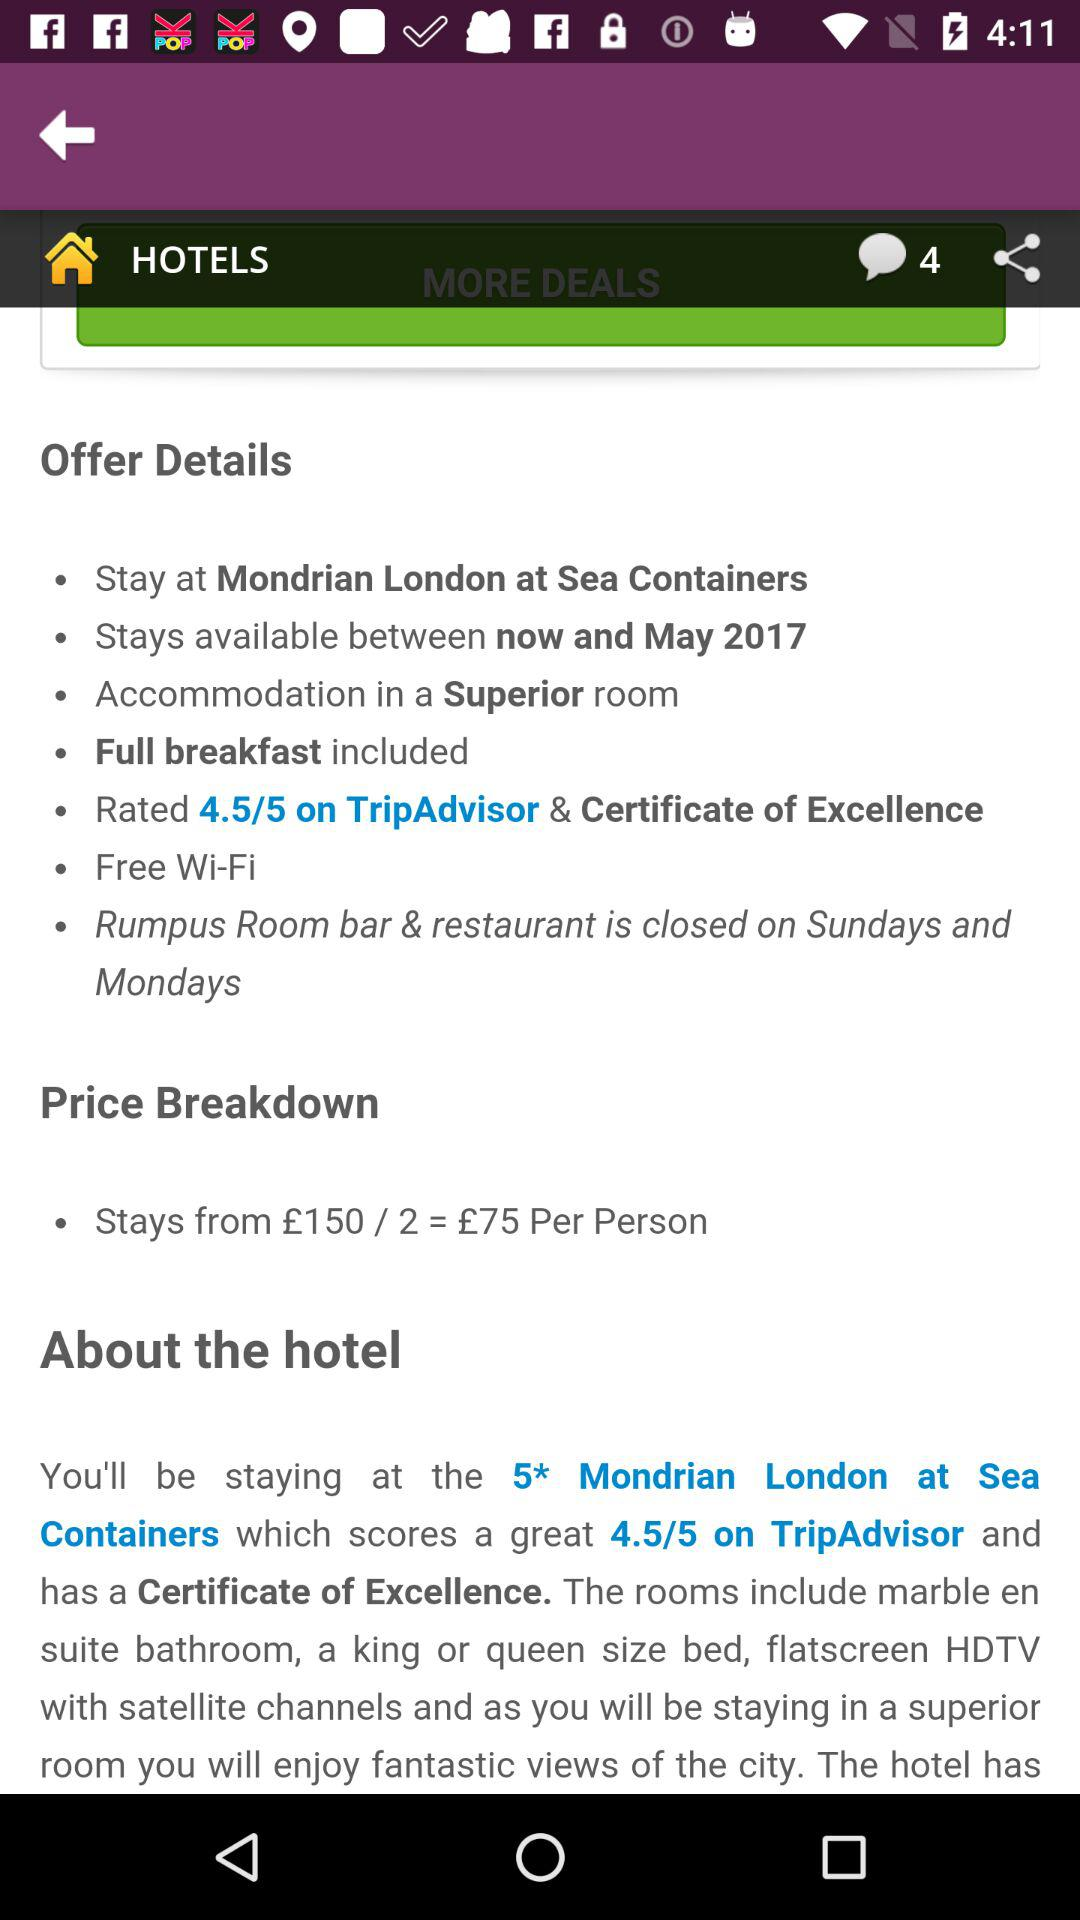What is the number of unread messages? There are four unread messages. 